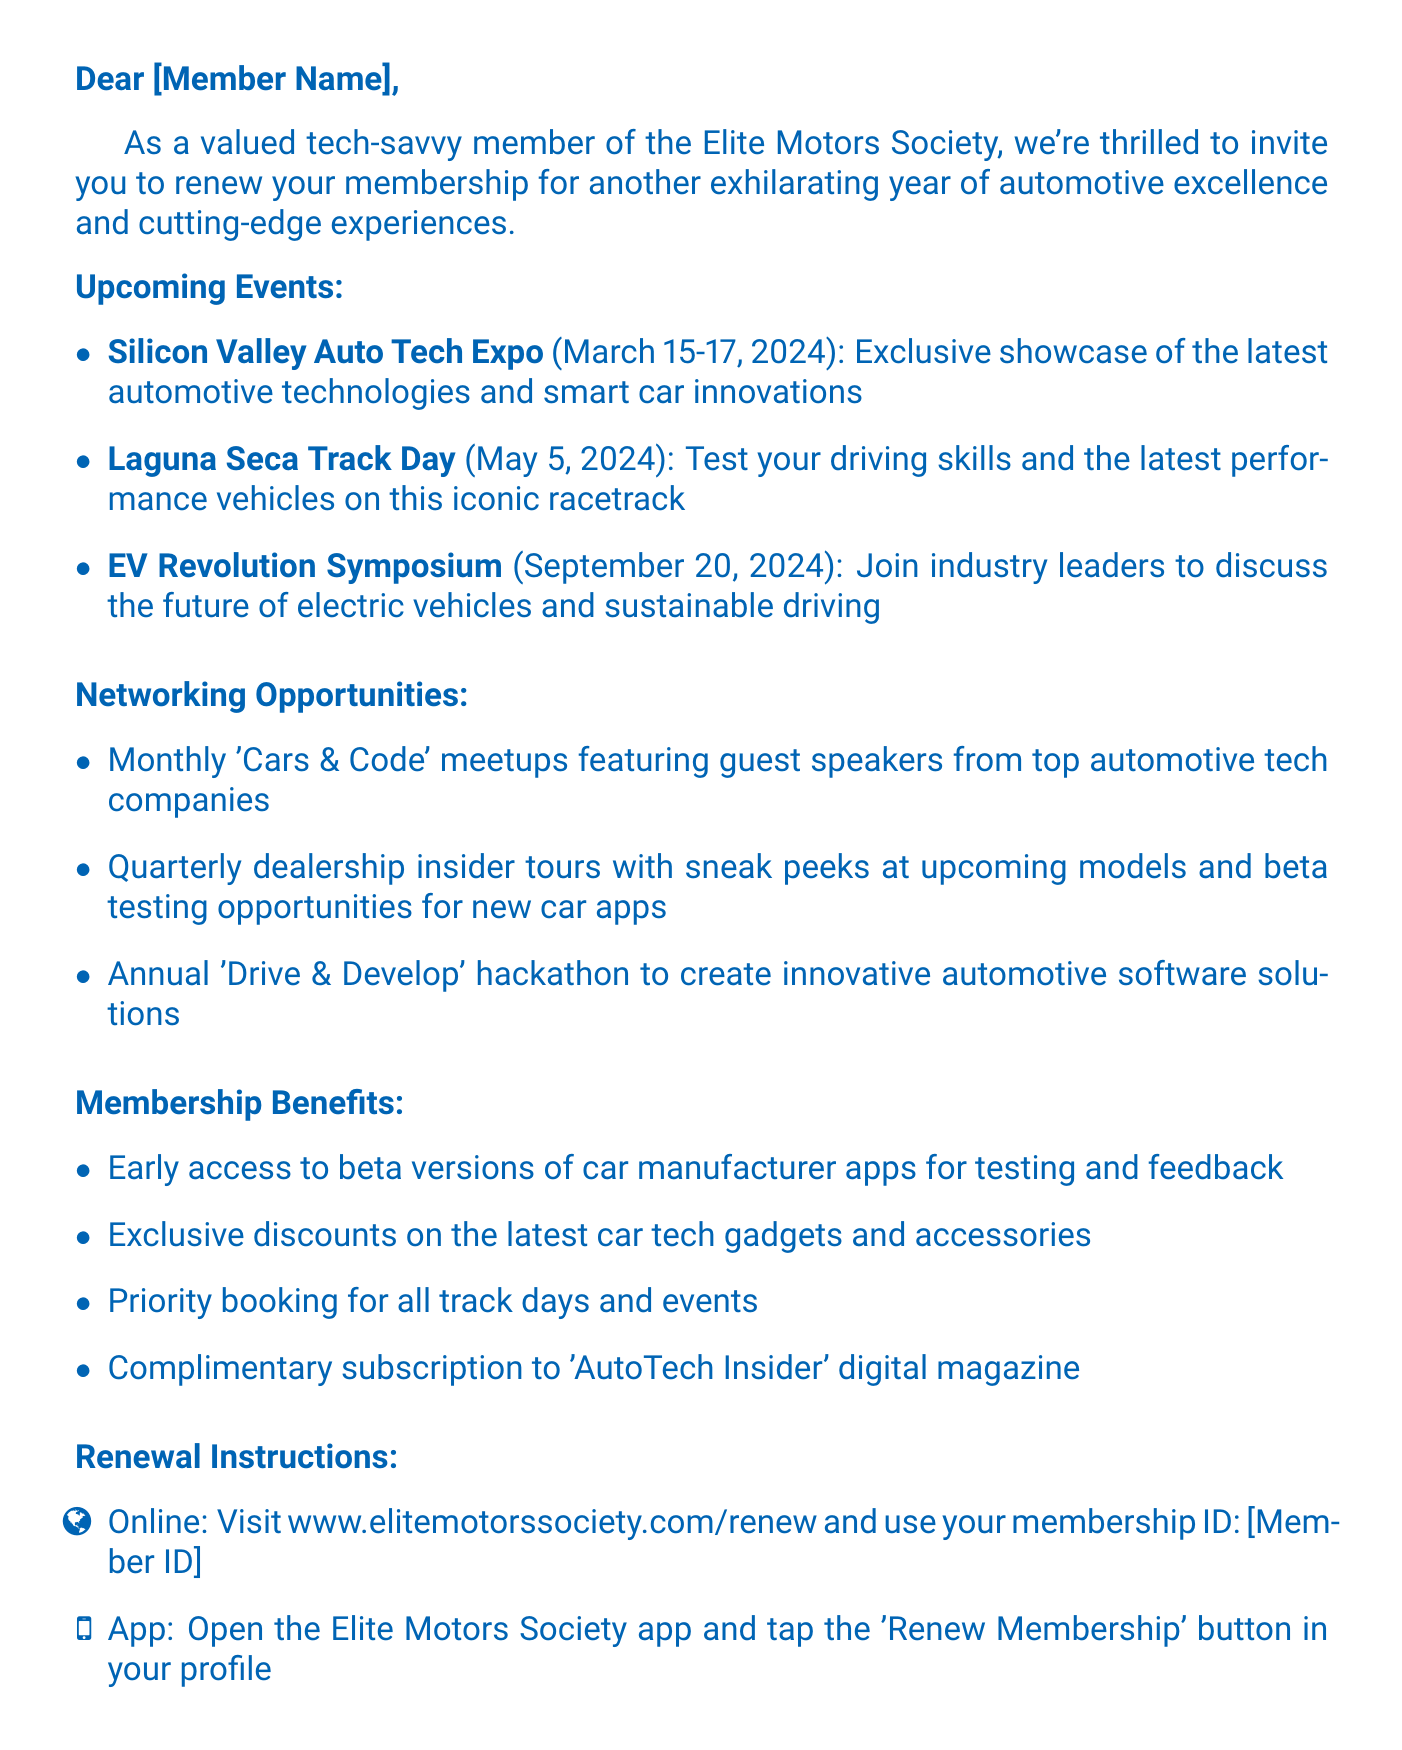What is the name of the club? The document specifies the club's name at the top in the header section.
Answer: Elite Motors Society When is the Laguna Seca Track Day? The date of the Laguna Seca Track Day is mentioned in the upcoming events section.
Answer: May 5, 2024 What is one of the networking opportunities mentioned? The document lists several networking opportunities in a dedicated section.
Answer: Monthly 'Cars & Code' meetups Who is the Membership Director? The signature section at the end of the document includes the name and title of the person.
Answer: Alexandra Turbo How can members renew their membership online? The renewal instructions provide details on how to renew membership online.
Answer: www.elitemotorssociety.com/renew What benefit is provided to members regarding digital magazines? The membership benefits list includes specific advantages for members related to publications.
Answer: Complimentary subscription to 'AutoTech Insider' digital magazine What is the date of the EV Revolution Symposium? This event's date is listed as part of the upcoming events section in the document.
Answer: September 20, 2024 What type of event is the Silicon Valley Auto Tech Expo? The description of the event details its nature in the upcoming events section.
Answer: Exclusive showcase of the latest automotive technologies and smart car innovations How many upcoming events are listed? The number of events can be counted from the upcoming events section.
Answer: Three 